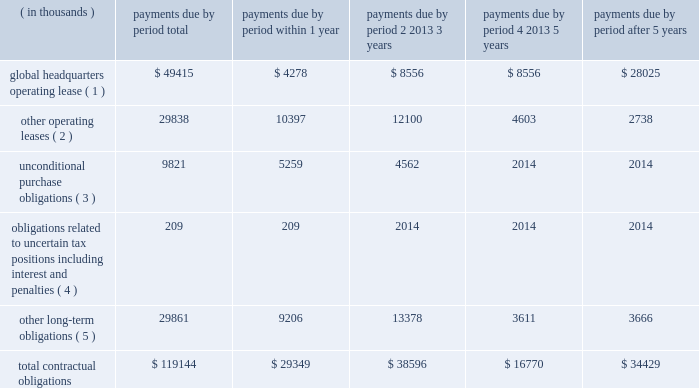Contractual obligations the company's significant contractual obligations as of december 31 , 2014 are summarized below: .
( 1 ) on september 14 , 2012 , the company entered into a lease agreement for 186000 square feet of rentable space located in an office facility in canonsburg , pennsylvania , which serves as the company's new headquarters .
The lease was effective as of september 14 , 2012 , but because the leased premises were under construction , the company was not obligated to pay rent until three months following the date that the leased premises were delivered to ansys , which occurred on october 1 , 2014 .
The term of the lease is 183 months , beginning on october 1 , 2014 .
The company shall have a one-time right to terminate the lease effective upon the last day of the tenth full year following the date of possession ( december 31 , 2024 ) , by providing the landlord with at least 18 months' prior written notice of such termination .
The company's lease for its prior headquarters expired on december 31 , 2014 .
( 2 ) other operating leases primarily include noncancellable lease commitments for the company 2019s other domestic and international offices as well as certain operating equipment .
( 3 ) unconditional purchase obligations primarily include software licenses and long-term purchase contracts for network , communication and office maintenance services , which are unrecorded as of december 31 , 2014 .
( 4 ) the company has $ 17.3 million of unrecognized tax benefits , including estimated interest and penalties , that have been recorded as liabilities in accordance with income tax accounting guidance for which the company is uncertain as to if or when such amounts may be settled .
As a result , such amounts are excluded from the table above .
( 5 ) other long-term obligations primarily include deferred compensation of $ 18.5 million ( including estimated imputed interest of $ 300000 within 1 year , $ 450000 within 2-3 years and $ 90000 within 4-5 years ) , pension obligations of $ 6.3 million for certain foreign locations of the company and contingent consideration of $ 2.8 million ( including estimated imputed interest of $ 270000 within 1 year and $ 390000 within 2-3 years ) .
Table of contents .
As of september 2014 what was the percent of the total contractual obligations due within 1 year for the global headquarters operating lease? 
Computations: (49415 / 119144)
Answer: 0.41475. 